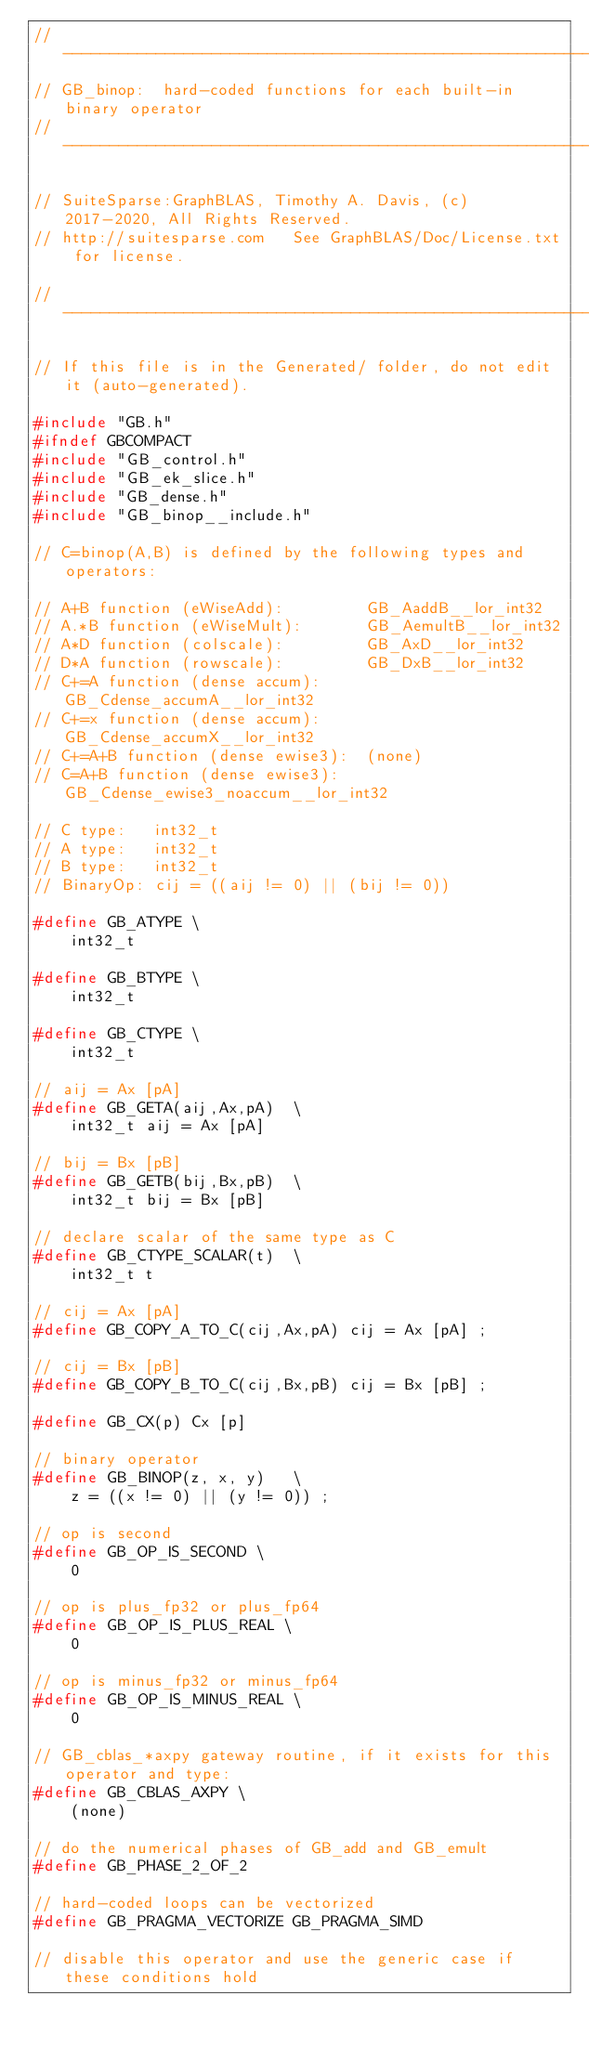Convert code to text. <code><loc_0><loc_0><loc_500><loc_500><_C_>//------------------------------------------------------------------------------
// GB_binop:  hard-coded functions for each built-in binary operator
//------------------------------------------------------------------------------

// SuiteSparse:GraphBLAS, Timothy A. Davis, (c) 2017-2020, All Rights Reserved.
// http://suitesparse.com   See GraphBLAS/Doc/License.txt for license.

//------------------------------------------------------------------------------

// If this file is in the Generated/ folder, do not edit it (auto-generated).

#include "GB.h"
#ifndef GBCOMPACT
#include "GB_control.h"
#include "GB_ek_slice.h"
#include "GB_dense.h"
#include "GB_binop__include.h"

// C=binop(A,B) is defined by the following types and operators:

// A+B function (eWiseAdd):         GB_AaddB__lor_int32
// A.*B function (eWiseMult):       GB_AemultB__lor_int32
// A*D function (colscale):         GB_AxD__lor_int32
// D*A function (rowscale):         GB_DxB__lor_int32
// C+=A function (dense accum):     GB_Cdense_accumA__lor_int32
// C+=x function (dense accum):     GB_Cdense_accumX__lor_int32
// C+=A+B function (dense ewise3):  (none)
// C=A+B function (dense ewise3):   GB_Cdense_ewise3_noaccum__lor_int32

// C type:   int32_t
// A type:   int32_t
// B type:   int32_t
// BinaryOp: cij = ((aij != 0) || (bij != 0))

#define GB_ATYPE \
    int32_t

#define GB_BTYPE \
    int32_t

#define GB_CTYPE \
    int32_t

// aij = Ax [pA]
#define GB_GETA(aij,Ax,pA)  \
    int32_t aij = Ax [pA]

// bij = Bx [pB]
#define GB_GETB(bij,Bx,pB)  \
    int32_t bij = Bx [pB]

// declare scalar of the same type as C
#define GB_CTYPE_SCALAR(t)  \
    int32_t t

// cij = Ax [pA]
#define GB_COPY_A_TO_C(cij,Ax,pA) cij = Ax [pA] ;

// cij = Bx [pB]
#define GB_COPY_B_TO_C(cij,Bx,pB) cij = Bx [pB] ;

#define GB_CX(p) Cx [p]

// binary operator
#define GB_BINOP(z, x, y)   \
    z = ((x != 0) || (y != 0)) ;

// op is second
#define GB_OP_IS_SECOND \
    0

// op is plus_fp32 or plus_fp64
#define GB_OP_IS_PLUS_REAL \
    0

// op is minus_fp32 or minus_fp64
#define GB_OP_IS_MINUS_REAL \
    0

// GB_cblas_*axpy gateway routine, if it exists for this operator and type:
#define GB_CBLAS_AXPY \
    (none)

// do the numerical phases of GB_add and GB_emult
#define GB_PHASE_2_OF_2

// hard-coded loops can be vectorized
#define GB_PRAGMA_VECTORIZE GB_PRAGMA_SIMD

// disable this operator and use the generic case if these conditions hold</code> 